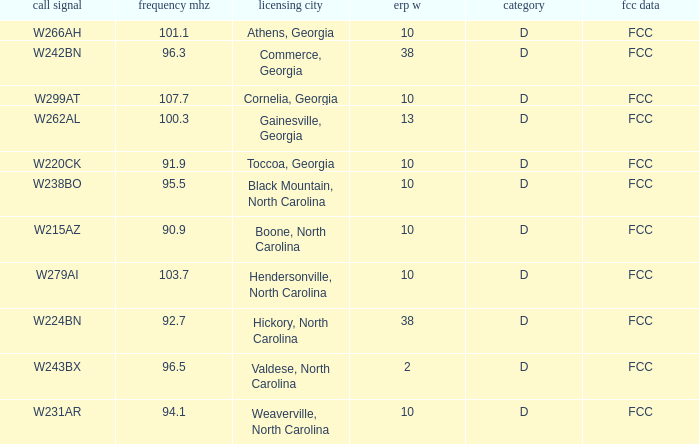What is the Frequency MHz for the station with a call sign of w224bn? 92.7. 